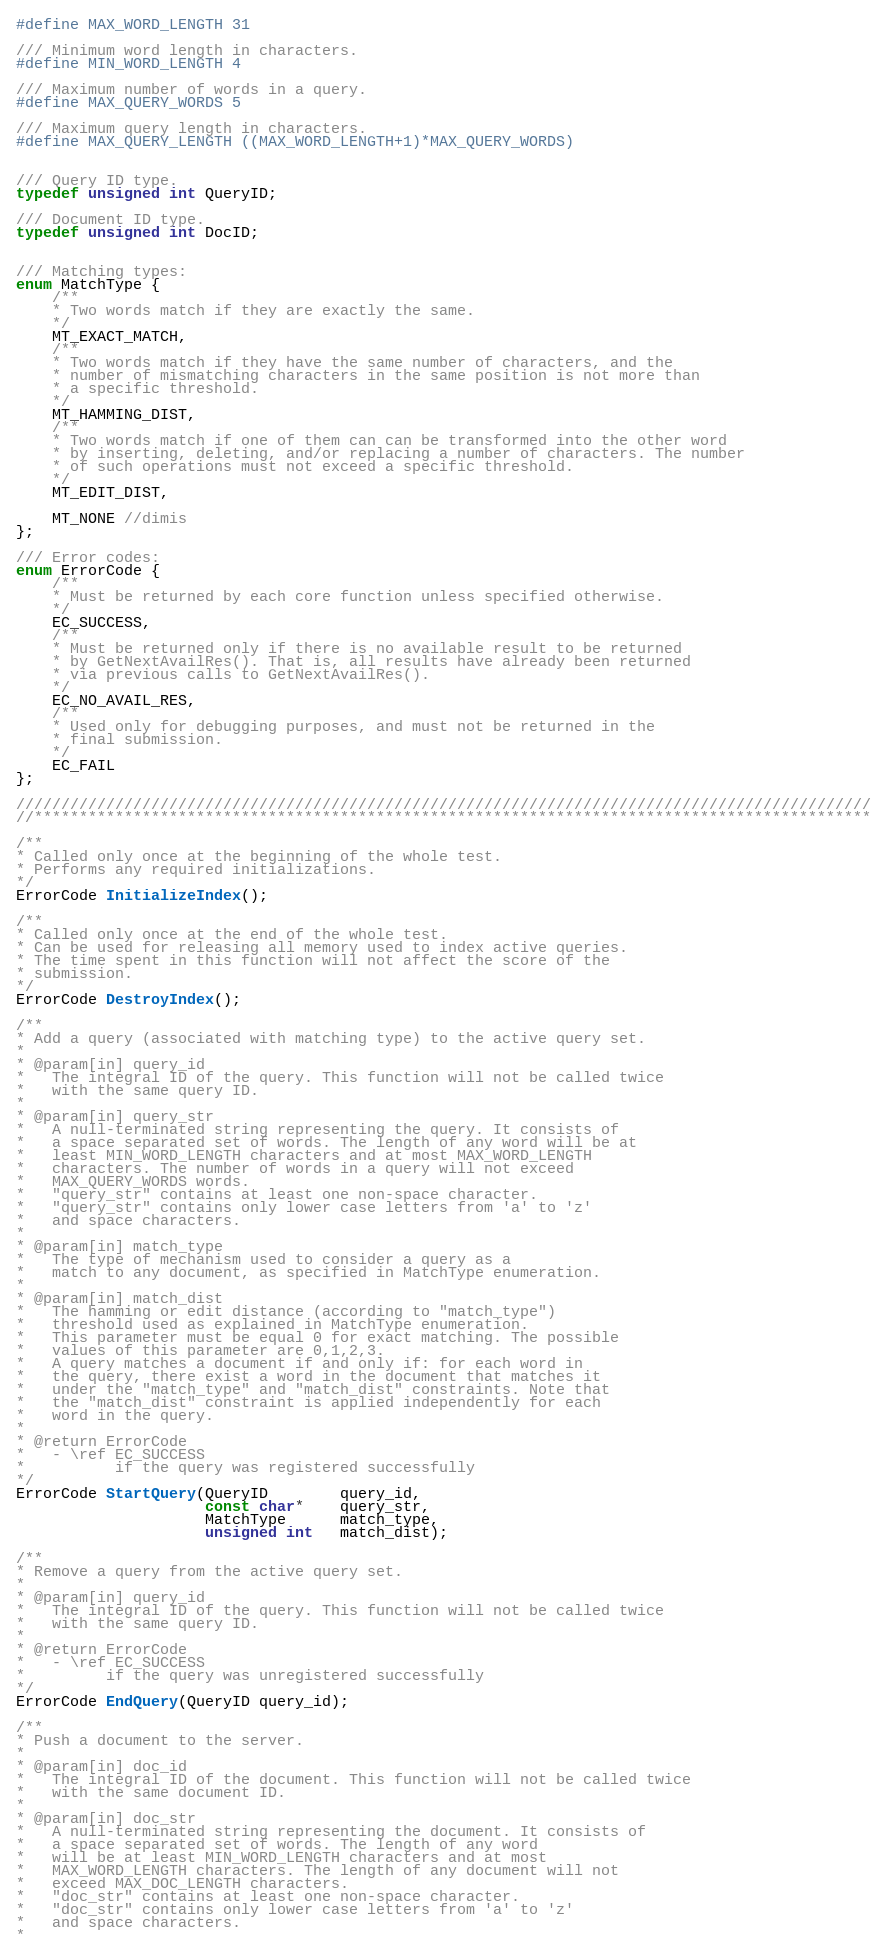<code> <loc_0><loc_0><loc_500><loc_500><_C_>#define MAX_WORD_LENGTH 31

/// Minimum word length in characters.
#define MIN_WORD_LENGTH 4

/// Maximum number of words in a query.
#define MAX_QUERY_WORDS 5

/// Maximum query length in characters.
#define MAX_QUERY_LENGTH ((MAX_WORD_LENGTH+1)*MAX_QUERY_WORDS)


/// Query ID type.
typedef unsigned int QueryID;

/// Document ID type.
typedef unsigned int DocID;


/// Matching types:
enum MatchType {
    /**
    * Two words match if they are exactly the same.
    */
    MT_EXACT_MATCH,
    /**
    * Two words match if they have the same number of characters, and the
    * number of mismatching characters in the same position is not more than
    * a specific threshold.
    */
    MT_HAMMING_DIST,
    /**
    * Two words match if one of them can can be transformed into the other word
    * by inserting, deleting, and/or replacing a number of characters. The number
    * of such operations must not exceed a specific threshold.
    */
    MT_EDIT_DIST,
    
    MT_NONE //dimis
};

/// Error codes:			
enum ErrorCode {
    /**
    * Must be returned by each core function unless specified otherwise.
    */
    EC_SUCCESS,
    /**
    * Must be returned only if there is no available result to be returned
    * by GetNextAvailRes(). That is, all results have already been returned
    * via previous calls to GetNextAvailRes().
    */
    EC_NO_AVAIL_RES,
    /**
    * Used only for debugging purposes, and must not be returned in the
    * final submission.
    */
    EC_FAIL
};

///////////////////////////////////////////////////////////////////////////////////////////////
//*********************************************************************************************

/**
* Called only once at the beginning of the whole test.
* Performs any required initializations. 
*/
ErrorCode InitializeIndex();

/**
* Called only once at the end of the whole test.
* Can be used for releasing all memory used to index active queries.
* The time spent in this function will not affect the score of the
* submission.
*/
ErrorCode DestroyIndex();

/**
* Add a query (associated with matching type) to the active query set.
* 
* @param[in] query_id
*   The integral ID of the query. This function will not be called twice
*   with the same query ID.
*
* @param[in] query_str
*   A null-terminated string representing the query. It consists of
*   a space separated set of words. The length of any word will be at
*	least MIN_WORD_LENGTH characters and at most MAX_WORD_LENGTH
*	characters. The number of words in a query will not exceed
*	MAX_QUERY_WORDS words.
*   "query_str" contains at least one non-space character.
*   "query_str" contains only lower case letters from 'a' to 'z'
*   and space characters.
* 
* @param[in] match_type
*   The type of mechanism used to consider a query as a
*   match to any document, as specified in MatchType enumeration.
*
* @param[in] match_dist
*   The hamming or edit distance (according to "match_type")
*   threshold used as explained in MatchType enumeration.
*   This parameter must be equal 0 for exact matching. The possible
*   values of this parameter are 0,1,2,3.
*   A query matches a document if and only if: for each word in
*	the query, there exist a word in the document that matches it
*	under the "match_type" and "match_dist" constraints. Note that
*	the "match_dist" constraint is applied independently for each
*	word in the query.
*
* @return ErrorCode
*   - \ref EC_SUCCESS
*          if the query was registered successfully
*/
ErrorCode StartQuery(QueryID        query_id,
                     const char*    query_str,
                     MatchType      match_type,
                     unsigned int   match_dist);

/**
* Remove a query from the active query set.
*
* @param[in] query_id
*   The integral ID of the query. This function will not be called twice
*   with the same query ID.
*
* @return ErrorCode
*   - \ref EC_SUCCESS
*         if the query was unregistered successfully
*/
ErrorCode EndQuery(QueryID query_id);

/**
* Push a document to the server.
*
* @param[in] doc_id
*   The integral ID of the document. This function will not be called twice
*   with the same document ID.
*
* @param[in] doc_str
*   A null-terminated string representing the document. It consists of
*   a space separated set of words. The length of any word
*   will be at least MIN_WORD_LENGTH characters and at most
*	MAX_WORD_LENGTH characters. The length of any document will not
*   exceed MAX_DOC_LENGTH characters.
*   "doc_str" contains at least one non-space character.
*   "doc_str" contains only lower case letters from 'a' to 'z'
*   and space characters.
*</code> 